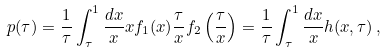Convert formula to latex. <formula><loc_0><loc_0><loc_500><loc_500>p ( \tau ) = \frac { 1 } { \tau } \int _ { \tau } ^ { 1 } \frac { d x } { x } x f _ { 1 } ( x ) \frac { \tau } { x } f _ { 2 } \left ( \frac { \tau } { x } \right ) = \frac { 1 } { \tau } \int _ { \tau } ^ { 1 } \frac { d x } { x } h ( x , \tau ) \, ,</formula> 